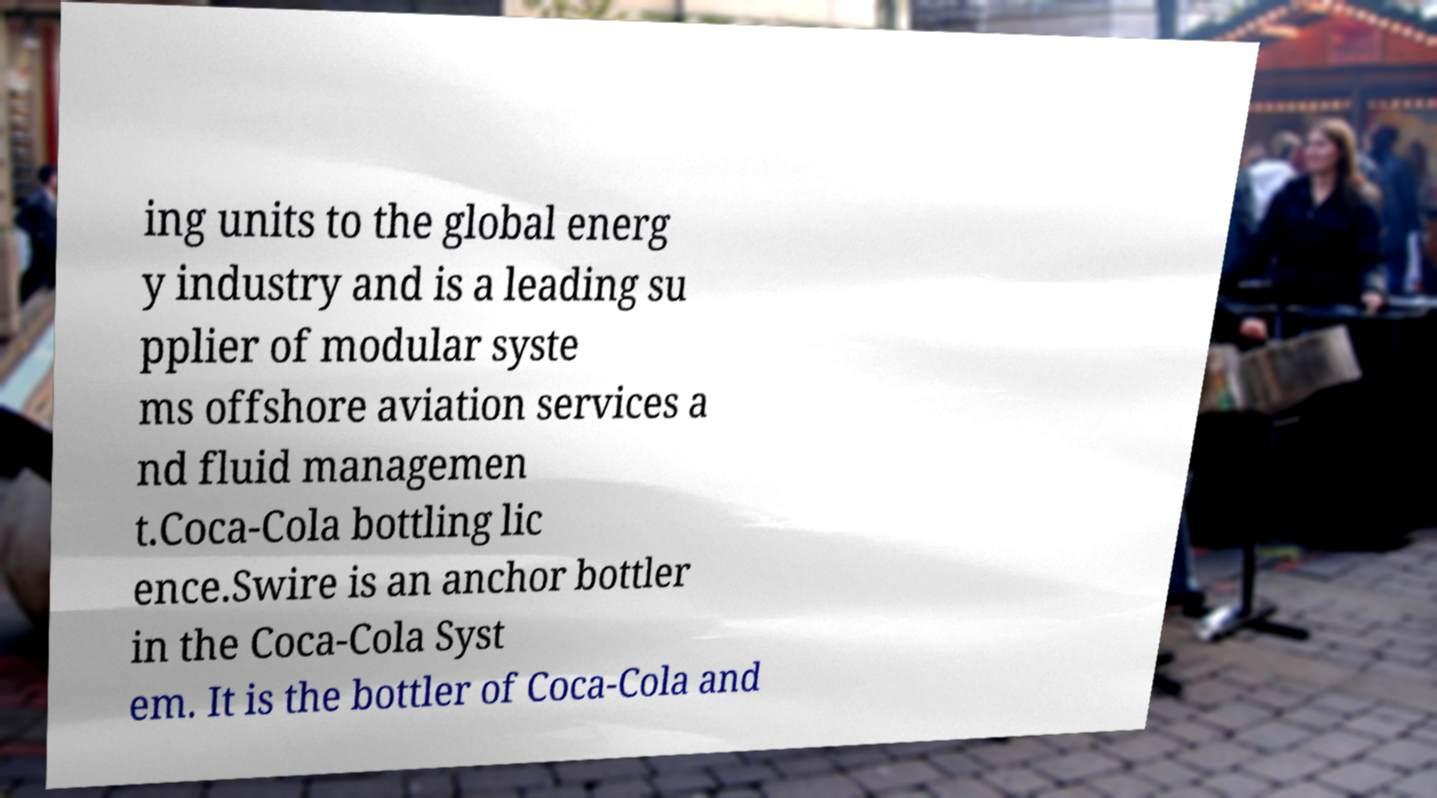Can you accurately transcribe the text from the provided image for me? ing units to the global energ y industry and is a leading su pplier of modular syste ms offshore aviation services a nd fluid managemen t.Coca-Cola bottling lic ence.Swire is an anchor bottler in the Coca-Cola Syst em. It is the bottler of Coca-Cola and 